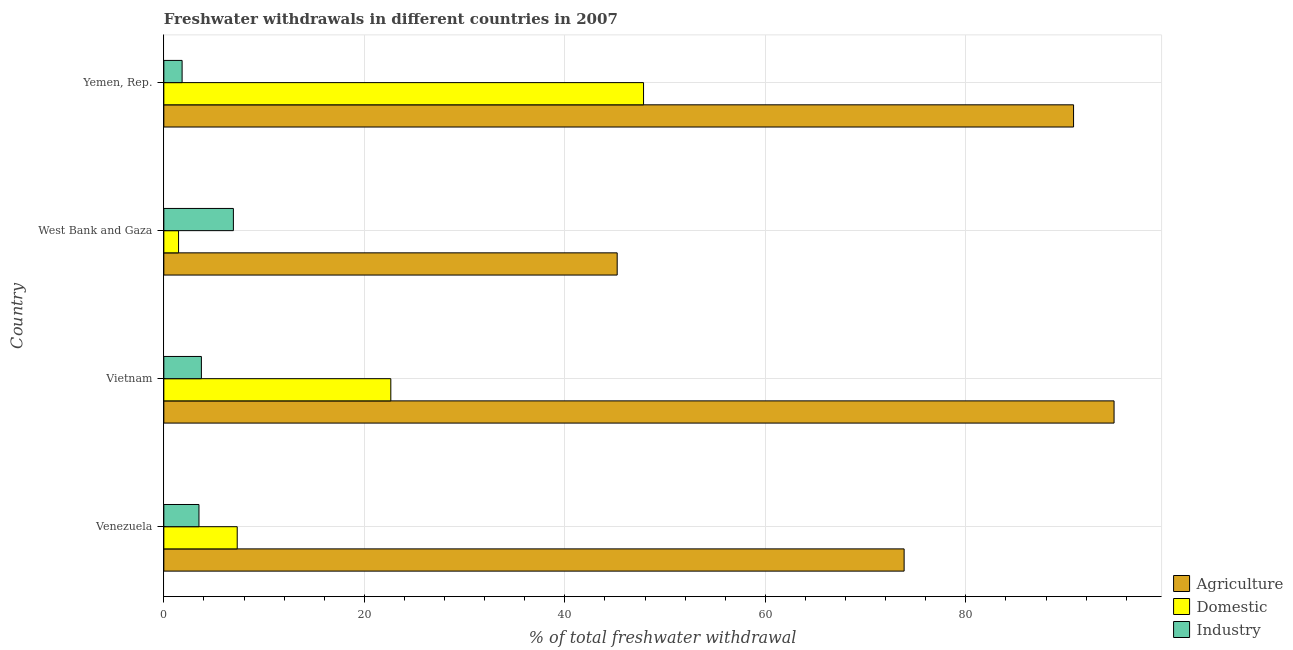What is the label of the 3rd group of bars from the top?
Your answer should be compact. Vietnam. In how many cases, is the number of bars for a given country not equal to the number of legend labels?
Provide a succinct answer. 0. What is the percentage of freshwater withdrawal for agriculture in Yemen, Rep.?
Provide a succinct answer. 90.74. Across all countries, what is the maximum percentage of freshwater withdrawal for agriculture?
Offer a very short reply. 94.78. Across all countries, what is the minimum percentage of freshwater withdrawal for industry?
Keep it short and to the point. 1.82. In which country was the percentage of freshwater withdrawal for domestic purposes maximum?
Ensure brevity in your answer.  Yemen, Rep. In which country was the percentage of freshwater withdrawal for domestic purposes minimum?
Give a very brief answer. West Bank and Gaza. What is the total percentage of freshwater withdrawal for industry in the graph?
Offer a terse response. 16.01. What is the difference between the percentage of freshwater withdrawal for domestic purposes in Venezuela and that in Vietnam?
Your response must be concise. -15.32. What is the difference between the percentage of freshwater withdrawal for domestic purposes in Venezuela and the percentage of freshwater withdrawal for agriculture in Vietnam?
Give a very brief answer. -87.46. What is the average percentage of freshwater withdrawal for agriculture per country?
Provide a short and direct response. 76.14. What is the difference between the percentage of freshwater withdrawal for industry and percentage of freshwater withdrawal for domestic purposes in Venezuela?
Ensure brevity in your answer.  -3.81. What is the ratio of the percentage of freshwater withdrawal for agriculture in Venezuela to that in West Bank and Gaza?
Offer a terse response. 1.63. Is the percentage of freshwater withdrawal for agriculture in Venezuela less than that in West Bank and Gaza?
Your answer should be very brief. No. Is the difference between the percentage of freshwater withdrawal for agriculture in Vietnam and West Bank and Gaza greater than the difference between the percentage of freshwater withdrawal for industry in Vietnam and West Bank and Gaza?
Keep it short and to the point. Yes. What is the difference between the highest and the second highest percentage of freshwater withdrawal for agriculture?
Ensure brevity in your answer.  4.04. What is the difference between the highest and the lowest percentage of freshwater withdrawal for industry?
Make the answer very short. 5.12. Is the sum of the percentage of freshwater withdrawal for domestic purposes in West Bank and Gaza and Yemen, Rep. greater than the maximum percentage of freshwater withdrawal for agriculture across all countries?
Keep it short and to the point. No. What does the 2nd bar from the top in Vietnam represents?
Ensure brevity in your answer.  Domestic. What does the 2nd bar from the bottom in West Bank and Gaza represents?
Keep it short and to the point. Domestic. How many countries are there in the graph?
Provide a short and direct response. 4. What is the difference between two consecutive major ticks on the X-axis?
Provide a short and direct response. 20. Are the values on the major ticks of X-axis written in scientific E-notation?
Give a very brief answer. No. Does the graph contain any zero values?
Provide a short and direct response. No. How many legend labels are there?
Provide a succinct answer. 3. How are the legend labels stacked?
Offer a very short reply. Vertical. What is the title of the graph?
Give a very brief answer. Freshwater withdrawals in different countries in 2007. Does "Industrial Nitrous Oxide" appear as one of the legend labels in the graph?
Your answer should be very brief. No. What is the label or title of the X-axis?
Your answer should be compact. % of total freshwater withdrawal. What is the % of total freshwater withdrawal of Agriculture in Venezuela?
Provide a short and direct response. 73.84. What is the % of total freshwater withdrawal of Domestic in Venezuela?
Your answer should be compact. 7.32. What is the % of total freshwater withdrawal in Industry in Venezuela?
Provide a succinct answer. 3.51. What is the % of total freshwater withdrawal of Agriculture in Vietnam?
Provide a succinct answer. 94.78. What is the % of total freshwater withdrawal in Domestic in Vietnam?
Your answer should be very brief. 22.64. What is the % of total freshwater withdrawal in Industry in Vietnam?
Provide a short and direct response. 3.75. What is the % of total freshwater withdrawal of Agriculture in West Bank and Gaza?
Ensure brevity in your answer.  45.22. What is the % of total freshwater withdrawal in Domestic in West Bank and Gaza?
Your answer should be very brief. 1.47. What is the % of total freshwater withdrawal in Industry in West Bank and Gaza?
Offer a terse response. 6.94. What is the % of total freshwater withdrawal of Agriculture in Yemen, Rep.?
Your response must be concise. 90.74. What is the % of total freshwater withdrawal of Domestic in Yemen, Rep.?
Keep it short and to the point. 47.85. What is the % of total freshwater withdrawal of Industry in Yemen, Rep.?
Your response must be concise. 1.82. Across all countries, what is the maximum % of total freshwater withdrawal of Agriculture?
Ensure brevity in your answer.  94.78. Across all countries, what is the maximum % of total freshwater withdrawal in Domestic?
Provide a short and direct response. 47.85. Across all countries, what is the maximum % of total freshwater withdrawal in Industry?
Your response must be concise. 6.94. Across all countries, what is the minimum % of total freshwater withdrawal of Agriculture?
Provide a succinct answer. 45.22. Across all countries, what is the minimum % of total freshwater withdrawal in Domestic?
Ensure brevity in your answer.  1.47. Across all countries, what is the minimum % of total freshwater withdrawal in Industry?
Keep it short and to the point. 1.82. What is the total % of total freshwater withdrawal in Agriculture in the graph?
Keep it short and to the point. 304.58. What is the total % of total freshwater withdrawal in Domestic in the graph?
Keep it short and to the point. 79.28. What is the total % of total freshwater withdrawal in Industry in the graph?
Make the answer very short. 16.01. What is the difference between the % of total freshwater withdrawal in Agriculture in Venezuela and that in Vietnam?
Make the answer very short. -20.94. What is the difference between the % of total freshwater withdrawal of Domestic in Venezuela and that in Vietnam?
Your answer should be compact. -15.32. What is the difference between the % of total freshwater withdrawal of Industry in Venezuela and that in Vietnam?
Provide a short and direct response. -0.24. What is the difference between the % of total freshwater withdrawal in Agriculture in Venezuela and that in West Bank and Gaza?
Offer a very short reply. 28.62. What is the difference between the % of total freshwater withdrawal of Domestic in Venezuela and that in West Bank and Gaza?
Give a very brief answer. 5.85. What is the difference between the % of total freshwater withdrawal in Industry in Venezuela and that in West Bank and Gaza?
Offer a terse response. -3.43. What is the difference between the % of total freshwater withdrawal of Agriculture in Venezuela and that in Yemen, Rep.?
Give a very brief answer. -16.9. What is the difference between the % of total freshwater withdrawal of Domestic in Venezuela and that in Yemen, Rep.?
Keep it short and to the point. -40.53. What is the difference between the % of total freshwater withdrawal of Industry in Venezuela and that in Yemen, Rep.?
Your answer should be very brief. 1.68. What is the difference between the % of total freshwater withdrawal in Agriculture in Vietnam and that in West Bank and Gaza?
Your response must be concise. 49.56. What is the difference between the % of total freshwater withdrawal in Domestic in Vietnam and that in West Bank and Gaza?
Offer a terse response. 21.17. What is the difference between the % of total freshwater withdrawal of Industry in Vietnam and that in West Bank and Gaza?
Offer a terse response. -3.19. What is the difference between the % of total freshwater withdrawal of Agriculture in Vietnam and that in Yemen, Rep.?
Give a very brief answer. 4.04. What is the difference between the % of total freshwater withdrawal of Domestic in Vietnam and that in Yemen, Rep.?
Your answer should be compact. -25.21. What is the difference between the % of total freshwater withdrawal in Industry in Vietnam and that in Yemen, Rep.?
Give a very brief answer. 1.92. What is the difference between the % of total freshwater withdrawal in Agriculture in West Bank and Gaza and that in Yemen, Rep.?
Keep it short and to the point. -45.52. What is the difference between the % of total freshwater withdrawal in Domestic in West Bank and Gaza and that in Yemen, Rep.?
Provide a short and direct response. -46.38. What is the difference between the % of total freshwater withdrawal of Industry in West Bank and Gaza and that in Yemen, Rep.?
Give a very brief answer. 5.12. What is the difference between the % of total freshwater withdrawal of Agriculture in Venezuela and the % of total freshwater withdrawal of Domestic in Vietnam?
Keep it short and to the point. 51.2. What is the difference between the % of total freshwater withdrawal in Agriculture in Venezuela and the % of total freshwater withdrawal in Industry in Vietnam?
Offer a very short reply. 70.09. What is the difference between the % of total freshwater withdrawal in Domestic in Venezuela and the % of total freshwater withdrawal in Industry in Vietnam?
Give a very brief answer. 3.57. What is the difference between the % of total freshwater withdrawal in Agriculture in Venezuela and the % of total freshwater withdrawal in Domestic in West Bank and Gaza?
Your answer should be compact. 72.37. What is the difference between the % of total freshwater withdrawal of Agriculture in Venezuela and the % of total freshwater withdrawal of Industry in West Bank and Gaza?
Your answer should be very brief. 66.9. What is the difference between the % of total freshwater withdrawal of Domestic in Venezuela and the % of total freshwater withdrawal of Industry in West Bank and Gaza?
Provide a succinct answer. 0.38. What is the difference between the % of total freshwater withdrawal of Agriculture in Venezuela and the % of total freshwater withdrawal of Domestic in Yemen, Rep.?
Your answer should be very brief. 25.99. What is the difference between the % of total freshwater withdrawal in Agriculture in Venezuela and the % of total freshwater withdrawal in Industry in Yemen, Rep.?
Give a very brief answer. 72.02. What is the difference between the % of total freshwater withdrawal of Domestic in Venezuela and the % of total freshwater withdrawal of Industry in Yemen, Rep.?
Your answer should be compact. 5.5. What is the difference between the % of total freshwater withdrawal in Agriculture in Vietnam and the % of total freshwater withdrawal in Domestic in West Bank and Gaza?
Keep it short and to the point. 93.31. What is the difference between the % of total freshwater withdrawal in Agriculture in Vietnam and the % of total freshwater withdrawal in Industry in West Bank and Gaza?
Your response must be concise. 87.84. What is the difference between the % of total freshwater withdrawal of Domestic in Vietnam and the % of total freshwater withdrawal of Industry in West Bank and Gaza?
Your response must be concise. 15.7. What is the difference between the % of total freshwater withdrawal in Agriculture in Vietnam and the % of total freshwater withdrawal in Domestic in Yemen, Rep.?
Your answer should be very brief. 46.93. What is the difference between the % of total freshwater withdrawal in Agriculture in Vietnam and the % of total freshwater withdrawal in Industry in Yemen, Rep.?
Provide a succinct answer. 92.96. What is the difference between the % of total freshwater withdrawal of Domestic in Vietnam and the % of total freshwater withdrawal of Industry in Yemen, Rep.?
Ensure brevity in your answer.  20.82. What is the difference between the % of total freshwater withdrawal in Agriculture in West Bank and Gaza and the % of total freshwater withdrawal in Domestic in Yemen, Rep.?
Your answer should be compact. -2.63. What is the difference between the % of total freshwater withdrawal of Agriculture in West Bank and Gaza and the % of total freshwater withdrawal of Industry in Yemen, Rep.?
Provide a short and direct response. 43.4. What is the difference between the % of total freshwater withdrawal of Domestic in West Bank and Gaza and the % of total freshwater withdrawal of Industry in Yemen, Rep.?
Provide a succinct answer. -0.35. What is the average % of total freshwater withdrawal in Agriculture per country?
Your answer should be compact. 76.14. What is the average % of total freshwater withdrawal in Domestic per country?
Provide a short and direct response. 19.82. What is the average % of total freshwater withdrawal in Industry per country?
Offer a very short reply. 4. What is the difference between the % of total freshwater withdrawal in Agriculture and % of total freshwater withdrawal in Domestic in Venezuela?
Offer a very short reply. 66.52. What is the difference between the % of total freshwater withdrawal in Agriculture and % of total freshwater withdrawal in Industry in Venezuela?
Your response must be concise. 70.33. What is the difference between the % of total freshwater withdrawal of Domestic and % of total freshwater withdrawal of Industry in Venezuela?
Your answer should be compact. 3.81. What is the difference between the % of total freshwater withdrawal in Agriculture and % of total freshwater withdrawal in Domestic in Vietnam?
Provide a short and direct response. 72.14. What is the difference between the % of total freshwater withdrawal in Agriculture and % of total freshwater withdrawal in Industry in Vietnam?
Give a very brief answer. 91.03. What is the difference between the % of total freshwater withdrawal of Domestic and % of total freshwater withdrawal of Industry in Vietnam?
Offer a very short reply. 18.89. What is the difference between the % of total freshwater withdrawal in Agriculture and % of total freshwater withdrawal in Domestic in West Bank and Gaza?
Your answer should be compact. 43.75. What is the difference between the % of total freshwater withdrawal in Agriculture and % of total freshwater withdrawal in Industry in West Bank and Gaza?
Your answer should be very brief. 38.28. What is the difference between the % of total freshwater withdrawal of Domestic and % of total freshwater withdrawal of Industry in West Bank and Gaza?
Offer a very short reply. -5.47. What is the difference between the % of total freshwater withdrawal in Agriculture and % of total freshwater withdrawal in Domestic in Yemen, Rep.?
Your response must be concise. 42.89. What is the difference between the % of total freshwater withdrawal of Agriculture and % of total freshwater withdrawal of Industry in Yemen, Rep.?
Your answer should be compact. 88.92. What is the difference between the % of total freshwater withdrawal of Domestic and % of total freshwater withdrawal of Industry in Yemen, Rep.?
Offer a terse response. 46.03. What is the ratio of the % of total freshwater withdrawal of Agriculture in Venezuela to that in Vietnam?
Keep it short and to the point. 0.78. What is the ratio of the % of total freshwater withdrawal in Domestic in Venezuela to that in Vietnam?
Offer a very short reply. 0.32. What is the ratio of the % of total freshwater withdrawal in Industry in Venezuela to that in Vietnam?
Make the answer very short. 0.94. What is the ratio of the % of total freshwater withdrawal in Agriculture in Venezuela to that in West Bank and Gaza?
Provide a short and direct response. 1.63. What is the ratio of the % of total freshwater withdrawal in Domestic in Venezuela to that in West Bank and Gaza?
Keep it short and to the point. 4.98. What is the ratio of the % of total freshwater withdrawal of Industry in Venezuela to that in West Bank and Gaza?
Keep it short and to the point. 0.51. What is the ratio of the % of total freshwater withdrawal of Agriculture in Venezuela to that in Yemen, Rep.?
Offer a terse response. 0.81. What is the ratio of the % of total freshwater withdrawal in Domestic in Venezuela to that in Yemen, Rep.?
Your response must be concise. 0.15. What is the ratio of the % of total freshwater withdrawal of Industry in Venezuela to that in Yemen, Rep.?
Offer a very short reply. 1.92. What is the ratio of the % of total freshwater withdrawal of Agriculture in Vietnam to that in West Bank and Gaza?
Ensure brevity in your answer.  2.1. What is the ratio of the % of total freshwater withdrawal in Domestic in Vietnam to that in West Bank and Gaza?
Your response must be concise. 15.4. What is the ratio of the % of total freshwater withdrawal of Industry in Vietnam to that in West Bank and Gaza?
Your answer should be very brief. 0.54. What is the ratio of the % of total freshwater withdrawal of Agriculture in Vietnam to that in Yemen, Rep.?
Make the answer very short. 1.04. What is the ratio of the % of total freshwater withdrawal in Domestic in Vietnam to that in Yemen, Rep.?
Keep it short and to the point. 0.47. What is the ratio of the % of total freshwater withdrawal in Industry in Vietnam to that in Yemen, Rep.?
Offer a very short reply. 2.06. What is the ratio of the % of total freshwater withdrawal of Agriculture in West Bank and Gaza to that in Yemen, Rep.?
Offer a terse response. 0.5. What is the ratio of the % of total freshwater withdrawal in Domestic in West Bank and Gaza to that in Yemen, Rep.?
Provide a short and direct response. 0.03. What is the ratio of the % of total freshwater withdrawal in Industry in West Bank and Gaza to that in Yemen, Rep.?
Keep it short and to the point. 3.81. What is the difference between the highest and the second highest % of total freshwater withdrawal in Agriculture?
Provide a succinct answer. 4.04. What is the difference between the highest and the second highest % of total freshwater withdrawal in Domestic?
Provide a short and direct response. 25.21. What is the difference between the highest and the second highest % of total freshwater withdrawal of Industry?
Ensure brevity in your answer.  3.19. What is the difference between the highest and the lowest % of total freshwater withdrawal in Agriculture?
Your response must be concise. 49.56. What is the difference between the highest and the lowest % of total freshwater withdrawal in Domestic?
Offer a very short reply. 46.38. What is the difference between the highest and the lowest % of total freshwater withdrawal of Industry?
Provide a succinct answer. 5.12. 